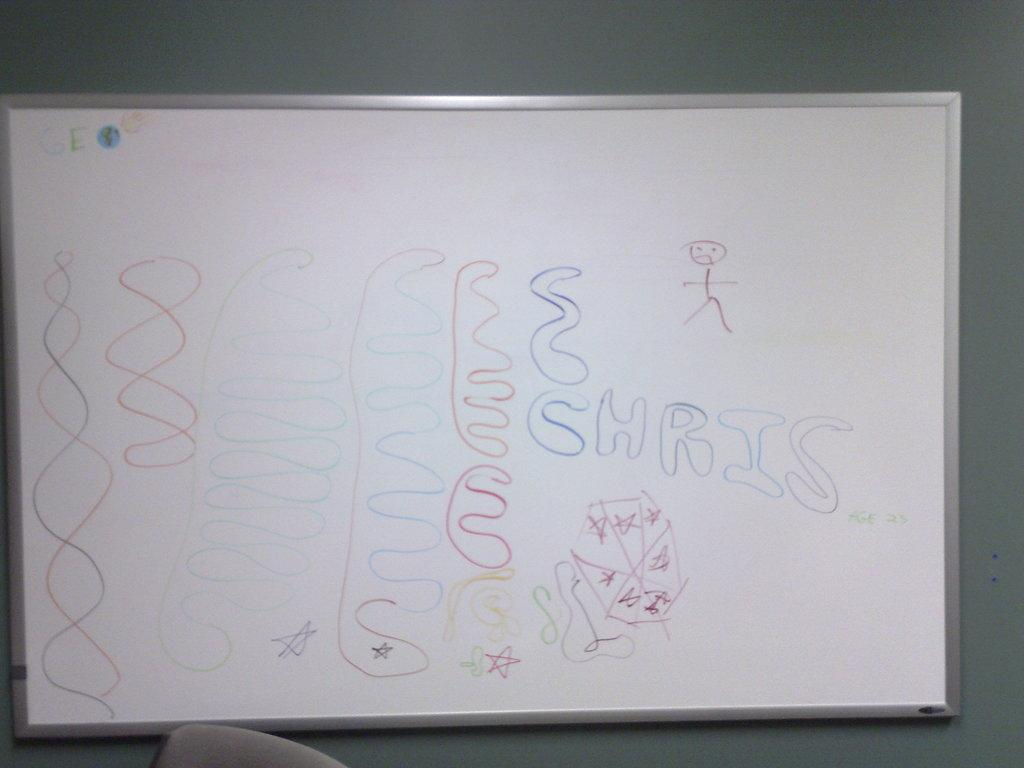<image>
Write a terse but informative summary of the picture. Chris is wrote on a white board that is connected to a wall. 